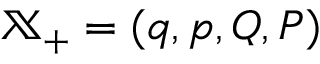<formula> <loc_0><loc_0><loc_500><loc_500>\mathbb { X } _ { + } = ( q , p , Q , P )</formula> 